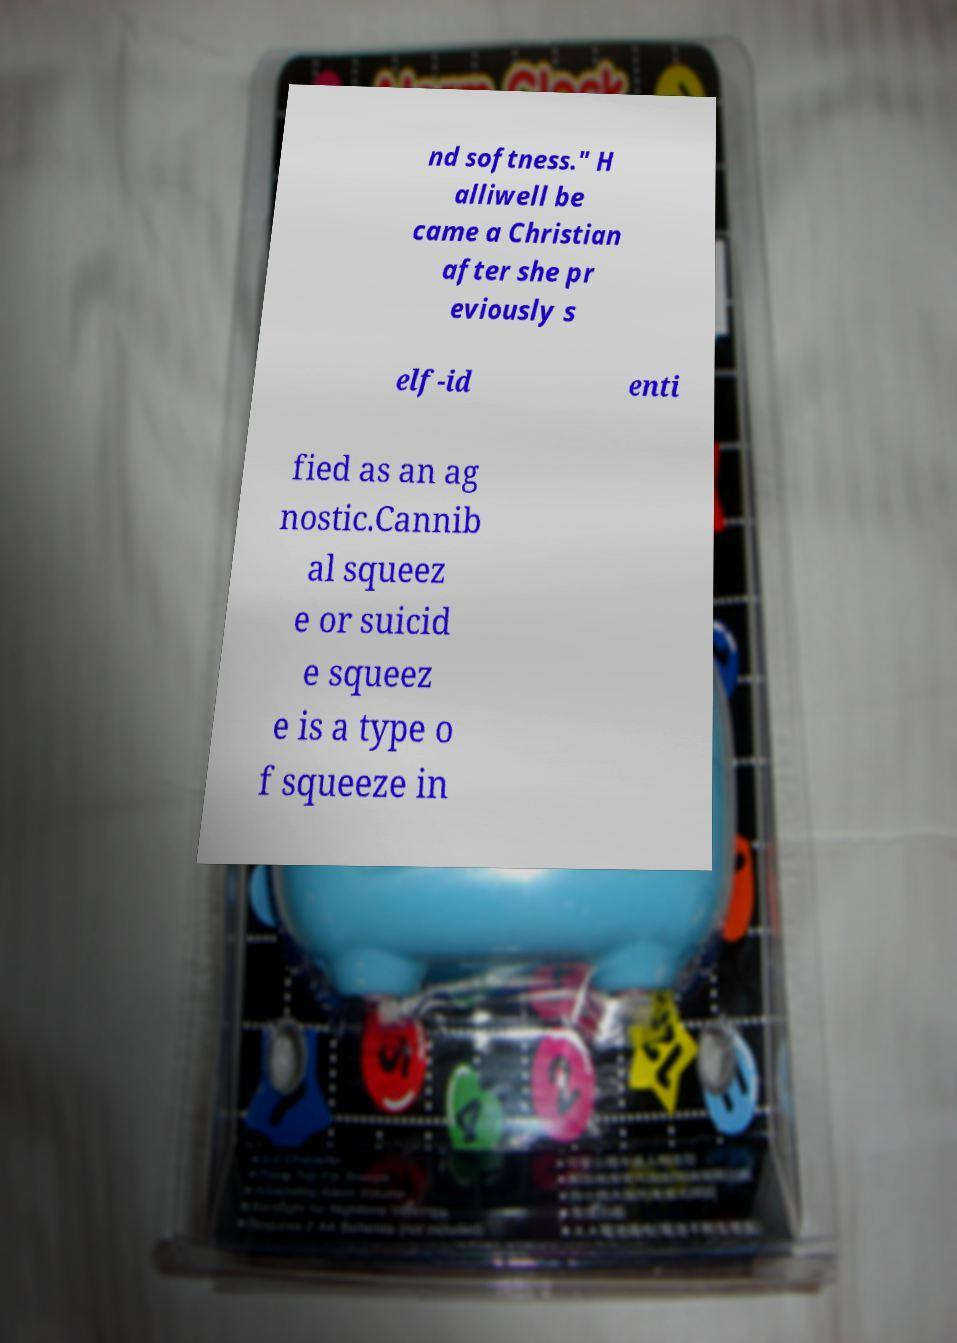Please identify and transcribe the text found in this image. nd softness." H alliwell be came a Christian after she pr eviously s elf-id enti fied as an ag nostic.Cannib al squeez e or suicid e squeez e is a type o f squeeze in 